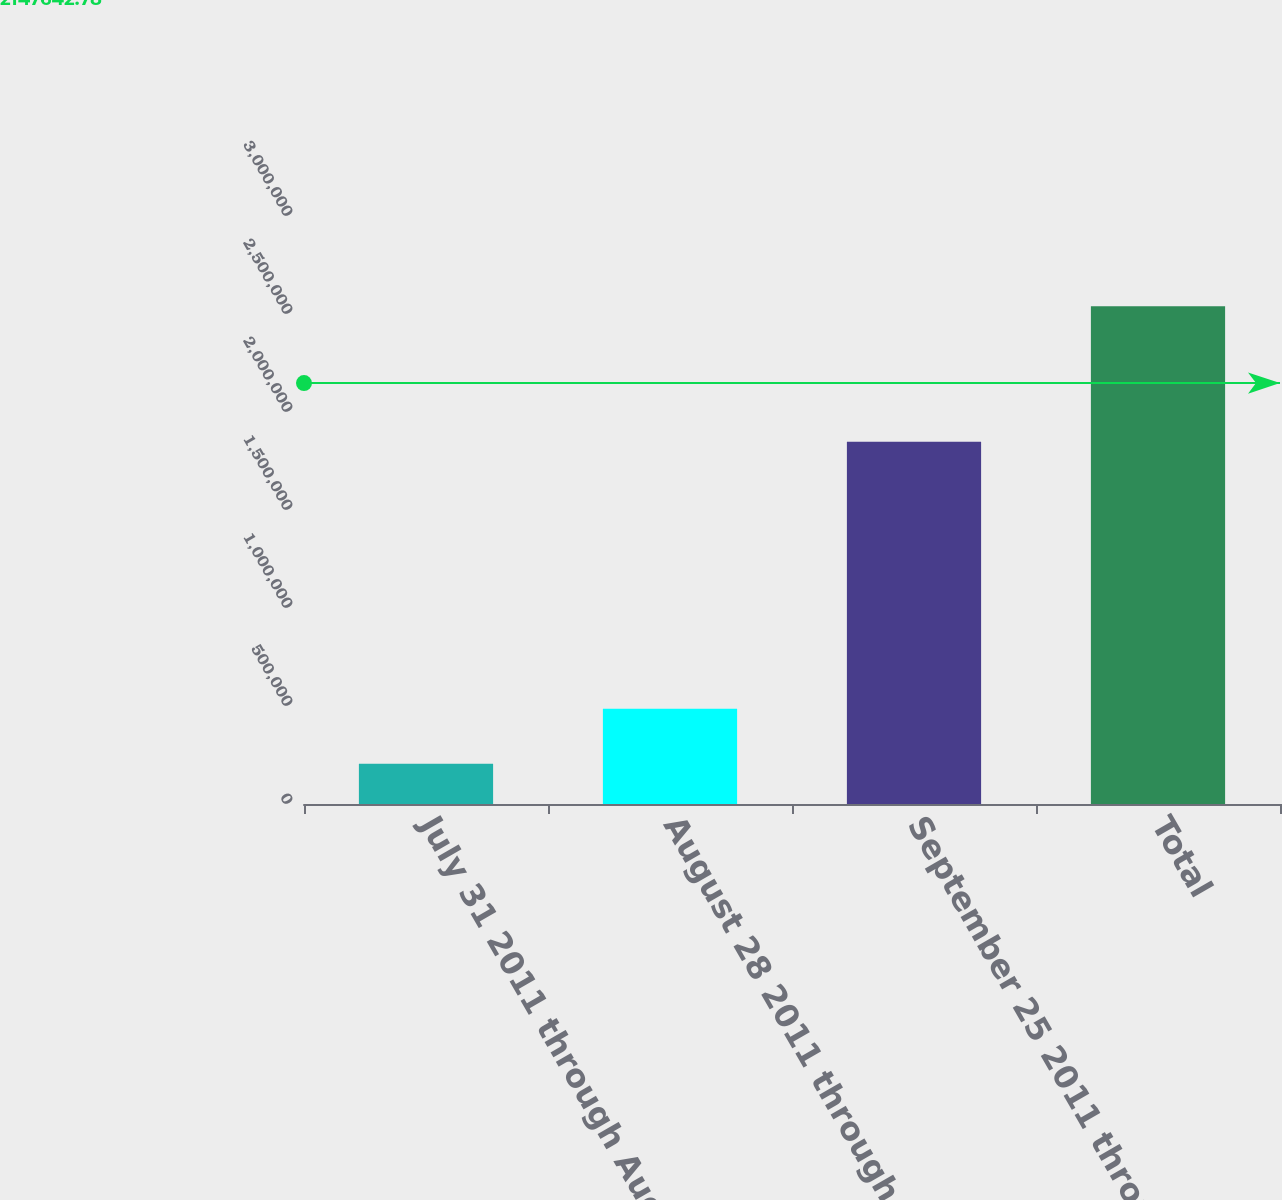Convert chart to OTSL. <chart><loc_0><loc_0><loc_500><loc_500><bar_chart><fcel>July 31 2011 through August 27<fcel>August 28 2011 through<fcel>September 25 2011 through<fcel>Total<nl><fcel>205946<fcel>486038<fcel>1.84769e+06<fcel>2.53967e+06<nl></chart> 